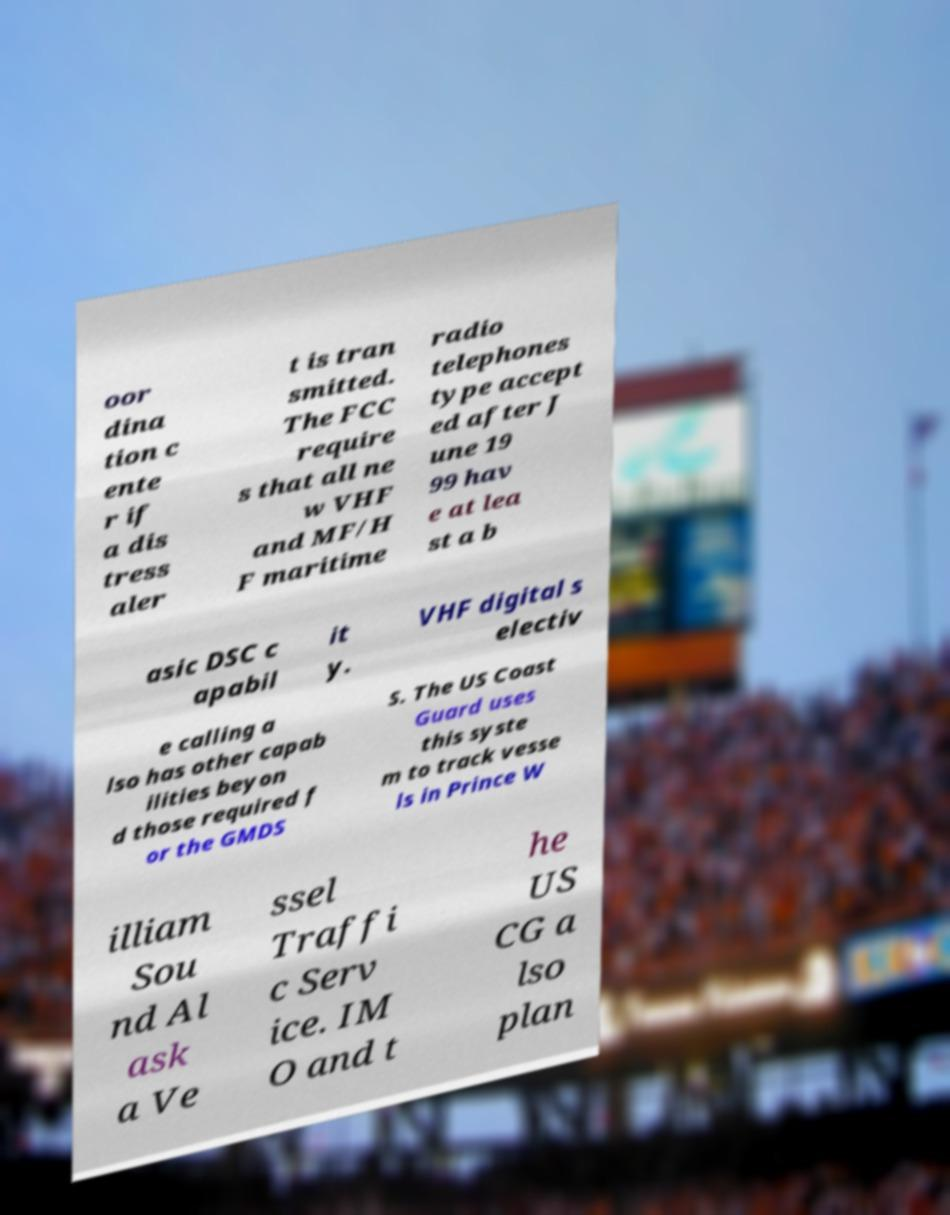Please identify and transcribe the text found in this image. oor dina tion c ente r if a dis tress aler t is tran smitted. The FCC require s that all ne w VHF and MF/H F maritime radio telephones type accept ed after J une 19 99 hav e at lea st a b asic DSC c apabil it y. VHF digital s electiv e calling a lso has other capab ilities beyon d those required f or the GMDS S. The US Coast Guard uses this syste m to track vesse ls in Prince W illiam Sou nd Al ask a Ve ssel Traffi c Serv ice. IM O and t he US CG a lso plan 